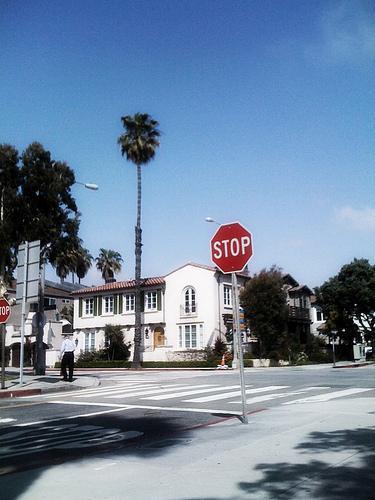How many STOP signs are in this photo?
Give a very brief answer. 2. 